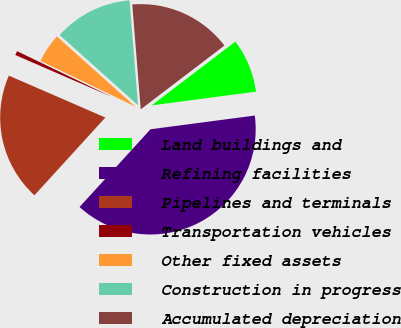Convert chart to OTSL. <chart><loc_0><loc_0><loc_500><loc_500><pie_chart><fcel>Land buildings and<fcel>Refining facilities<fcel>Pipelines and terminals<fcel>Transportation vehicles<fcel>Other fixed assets<fcel>Construction in progress<fcel>Accumulated depreciation<nl><fcel>8.28%<fcel>38.86%<fcel>19.75%<fcel>0.64%<fcel>4.46%<fcel>12.1%<fcel>15.92%<nl></chart> 